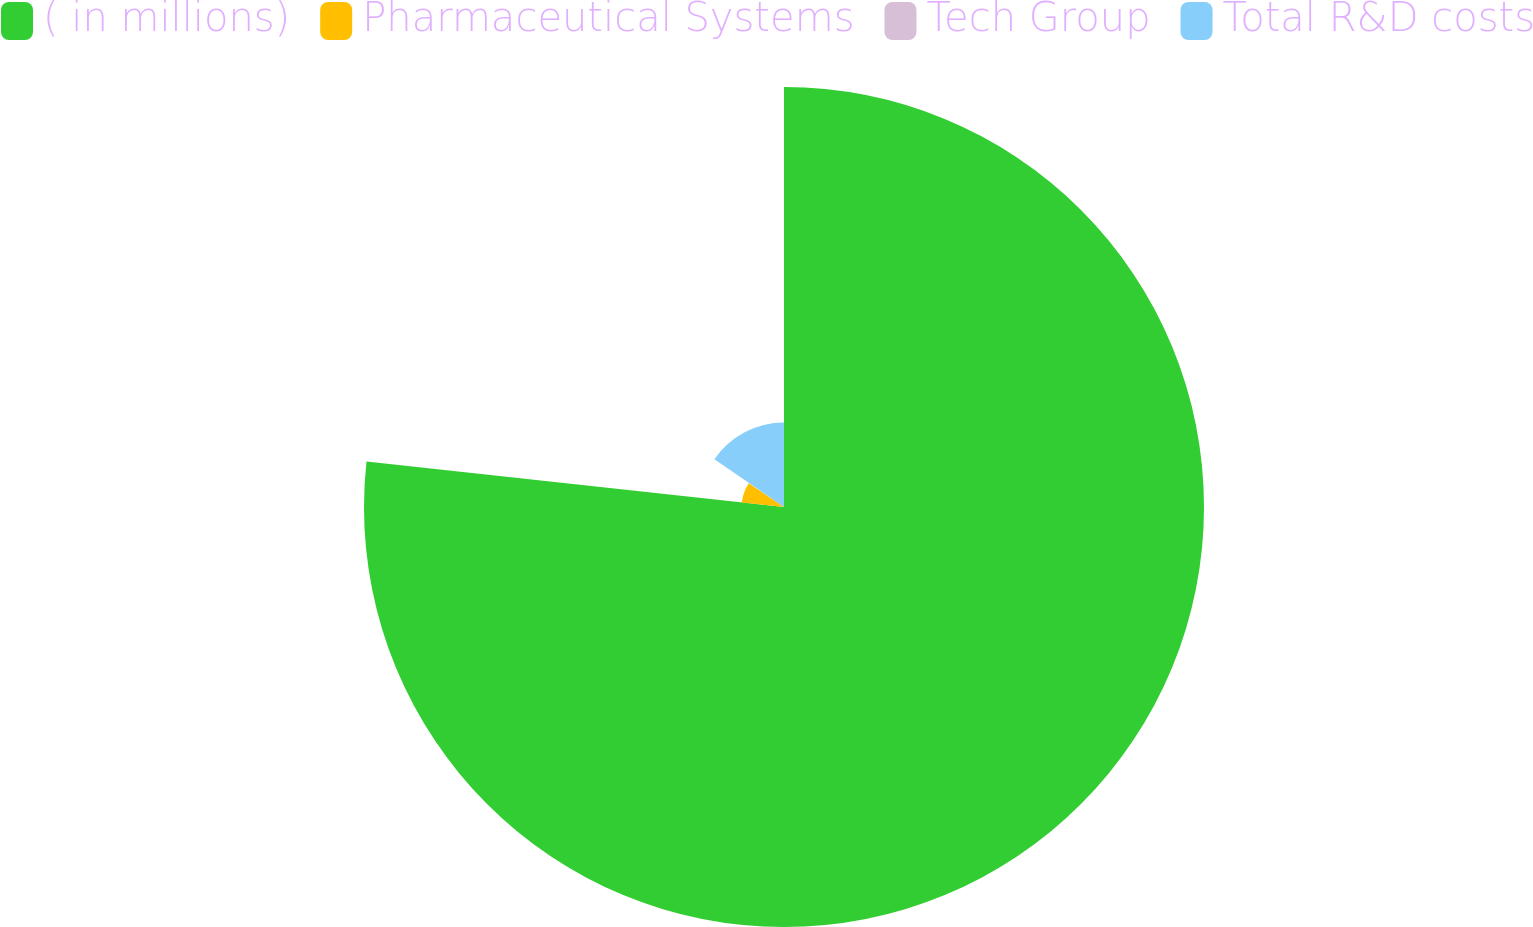<chart> <loc_0><loc_0><loc_500><loc_500><pie_chart><fcel>( in millions)<fcel>Pharmaceutical Systems<fcel>Tech Group<fcel>Total R&D costs<nl><fcel>76.73%<fcel>7.76%<fcel>0.09%<fcel>15.42%<nl></chart> 